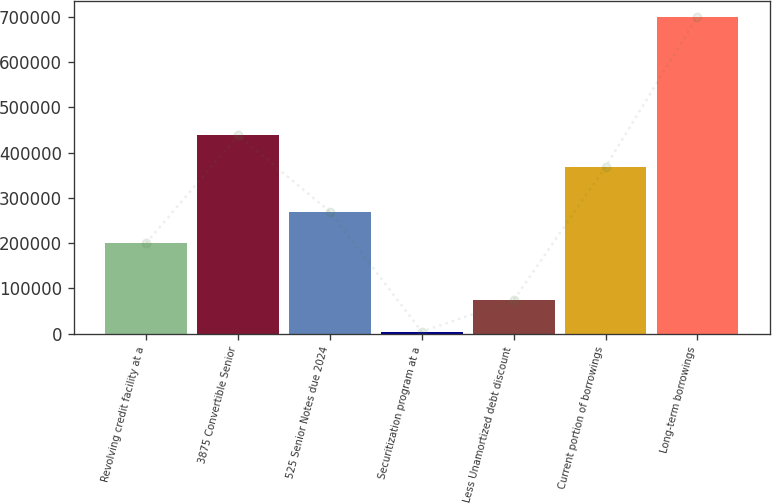<chart> <loc_0><loc_0><loc_500><loc_500><bar_chart><fcel>Revolving credit facility at a<fcel>3875 Convertible Senior<fcel>525 Senior Notes due 2024<fcel>Securitization program at a<fcel>Less Unamortized debt discount<fcel>Current portion of borrowings<fcel>Long-term borrowings<nl><fcel>200000<fcel>437931<fcel>269530<fcel>4700<fcel>74230<fcel>368401<fcel>700000<nl></chart> 